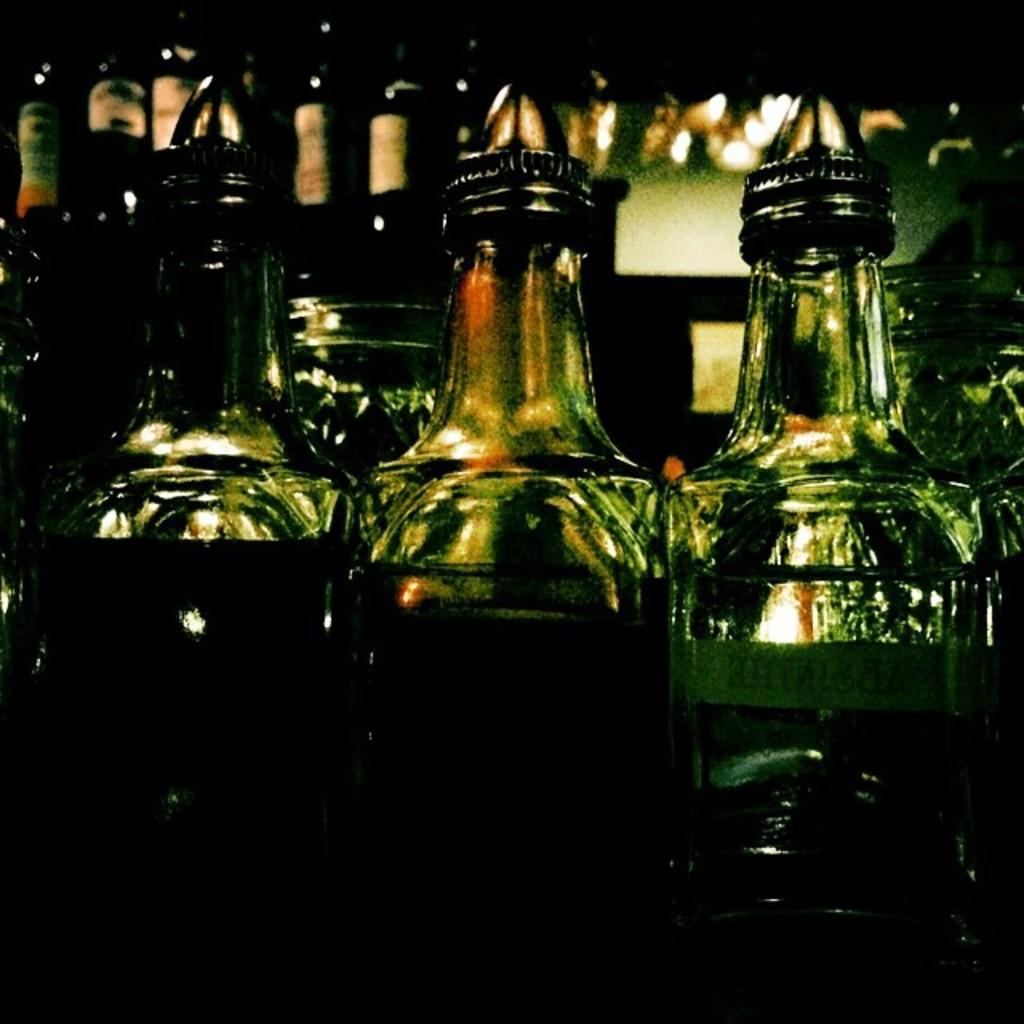Please provide a concise description of this image. In the picture there are many bottles with the liquid in it. 